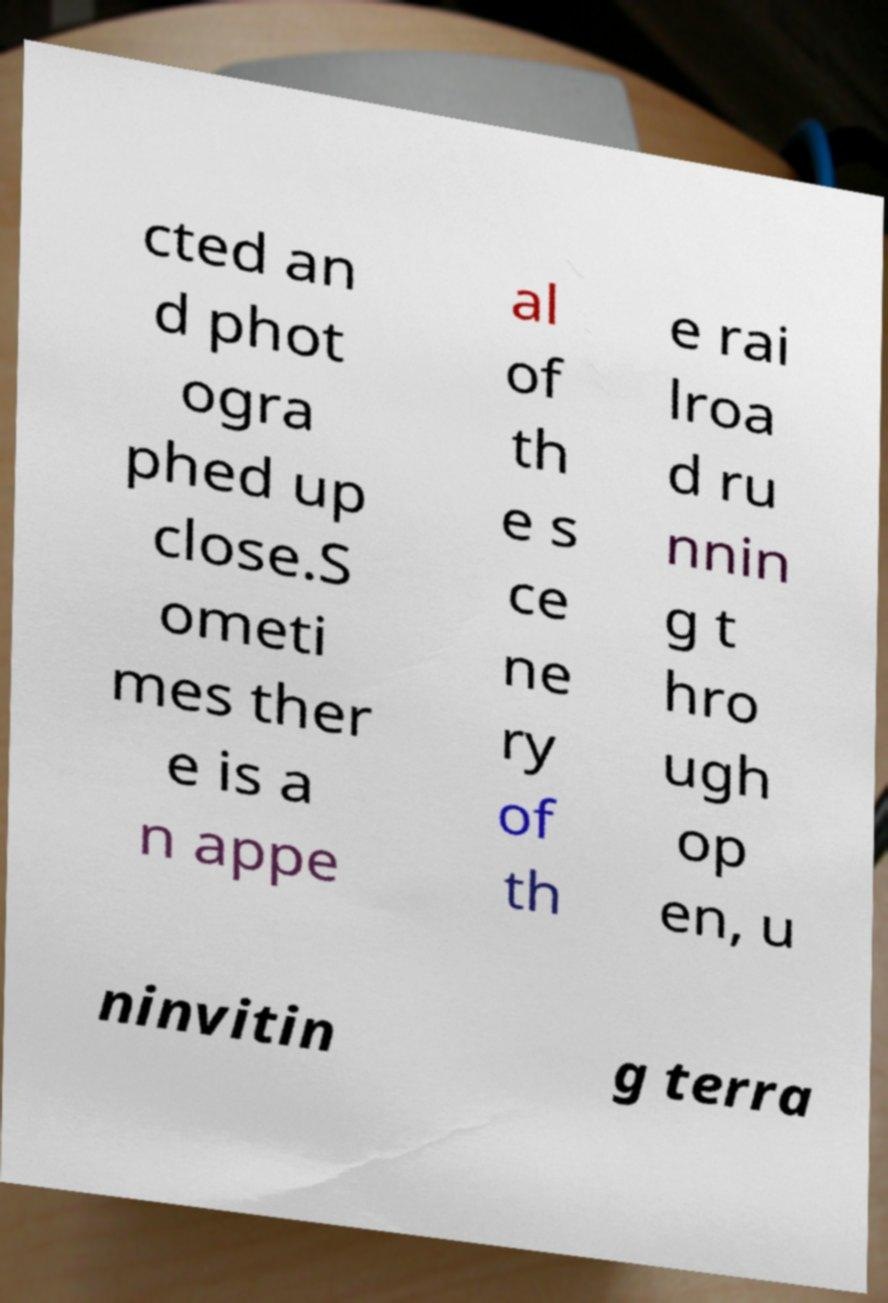There's text embedded in this image that I need extracted. Can you transcribe it verbatim? cted an d phot ogra phed up close.S ometi mes ther e is a n appe al of th e s ce ne ry of th e rai lroa d ru nnin g t hro ugh op en, u ninvitin g terra 